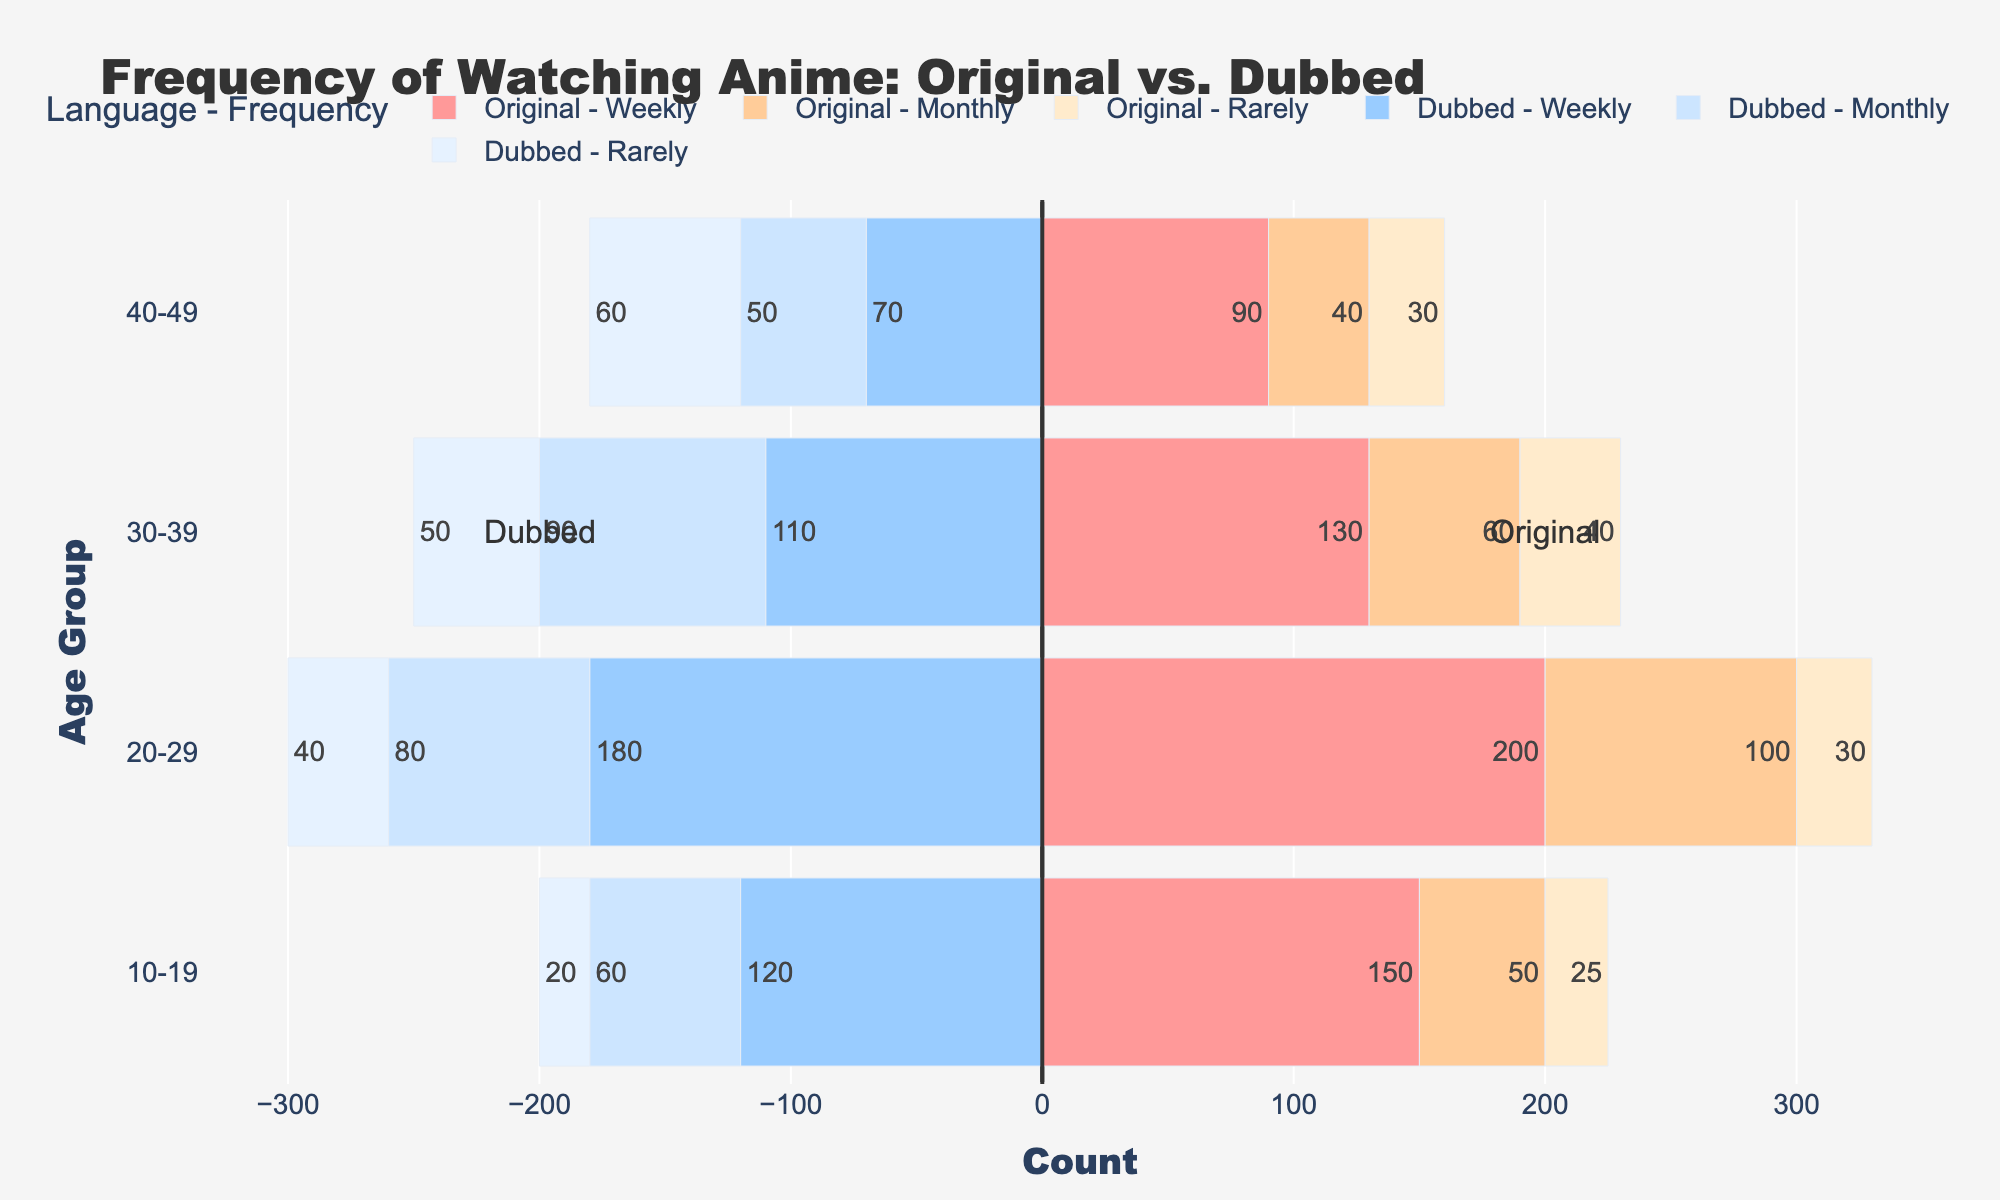What's the most common frequency of watching anime in the original language among the 20-29 age group? The largest segment bar for the 20-29 age group in the original language indicates that "Weekly" viewing is the most common.
Answer: Weekly Which age group watches dubbed anime weekly the least? Comparing the heights of the weekly frequency bars for dubbed anime across all age groups, the smallest bar belongs to the 40-49 age group.
Answer: 40-49 How much more frequently do 20-29-year-olds watch anime weekly in the original language compared to dubbed? The 20-29 age group has 200 counts for weekly original and 180 counts for weekly dubbed. The difference is 200 - 180.
Answer: 20 Which age group has the smallest difference in counts between those who watch original anime weekly and those who watch dubbed anime weekly? Calculate the absolute differences for each age group: 10-19 (150-120=30), 20-29 (200-180=20), 30-39 (130-110=20), 40-49 (90-70=20). The smallest difference is 20, present in the 20-29, 30-39, and 40-49 age groups.
Answer: 20-29, 30-39, 40-49 For the 30-39 age group, which frequency (weekly, monthly, rarely) has the highest total count when combining original and dubbed preferences? Summing the counts for each frequency: Weekly (130+110=240), Monthly (60+90=150), Rarely (40+50=90). Weekly has the highest combined total of 240.
Answer: Weekly (240) By how much do monthly viewers of dubbed anime decrease from the 20-29 age group to the 30-39 age group? Monthly viewers of dubbed anime in the 20-29 age group are 80, and for the 30-39 age group, they are 90. The decrease is 80 - 90 = -10 (an increase rather than a decrease).
Answer: -10 (increase) What is the visual feature used to distinguish between original and dubbed language preferences in the bar chart? The original and dubbed language preferences are differentiated by the direction of the bars; original language bars extend to the right while dubbed language bars extend to the left.
Answer: Bar direction Which is the least common frequency for watching anime in the original language across all age groups combined? Tallying counts for ("Rarely" - 10-19: 25, 20-29: 30, 30-39: 40, 40-49: 30), Monthly (10-19: 50, 20-29: 100, 30-39: 60, 40-49: 40), Weekly (10-19: 150, 20-29: 200, 30-39: 130, 40-49: 90). The sums are Rarely (125), Monthly (250), Weekly (570). The least common is Rarely.
Answer: Rarely (125) Which color represents monthly viewing frequencies of dubbed anime in the plot? The color for "Monthly" in dubbed anime can be seen from the legend and the corresponding bars which are light blue.
Answer: Light blue 